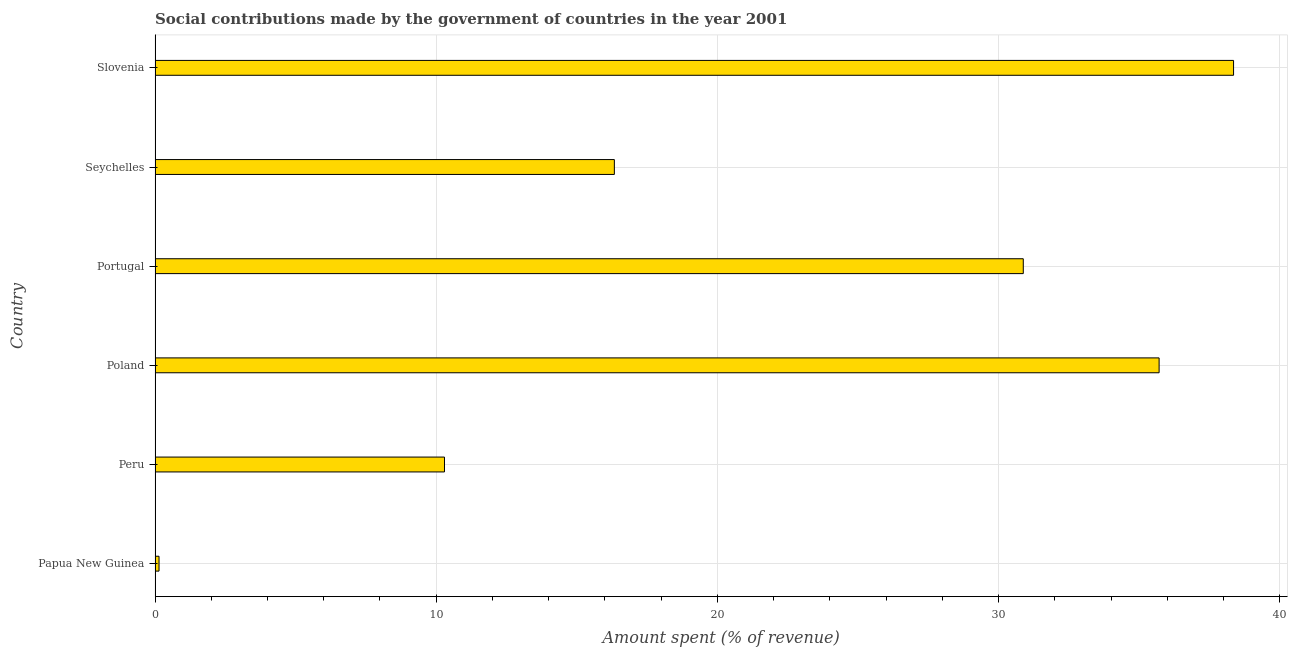What is the title of the graph?
Keep it short and to the point. Social contributions made by the government of countries in the year 2001. What is the label or title of the X-axis?
Your answer should be compact. Amount spent (% of revenue). What is the label or title of the Y-axis?
Offer a very short reply. Country. What is the amount spent in making social contributions in Poland?
Your response must be concise. 35.71. Across all countries, what is the maximum amount spent in making social contributions?
Provide a succinct answer. 38.36. Across all countries, what is the minimum amount spent in making social contributions?
Keep it short and to the point. 0.14. In which country was the amount spent in making social contributions maximum?
Give a very brief answer. Slovenia. In which country was the amount spent in making social contributions minimum?
Make the answer very short. Papua New Guinea. What is the sum of the amount spent in making social contributions?
Ensure brevity in your answer.  131.72. What is the difference between the amount spent in making social contributions in Papua New Guinea and Poland?
Your answer should be very brief. -35.57. What is the average amount spent in making social contributions per country?
Provide a succinct answer. 21.95. What is the median amount spent in making social contributions?
Your answer should be compact. 23.61. What is the ratio of the amount spent in making social contributions in Portugal to that in Slovenia?
Provide a succinct answer. 0.81. What is the difference between the highest and the second highest amount spent in making social contributions?
Ensure brevity in your answer.  2.65. What is the difference between the highest and the lowest amount spent in making social contributions?
Ensure brevity in your answer.  38.22. Are all the bars in the graph horizontal?
Your response must be concise. Yes. Are the values on the major ticks of X-axis written in scientific E-notation?
Ensure brevity in your answer.  No. What is the Amount spent (% of revenue) in Papua New Guinea?
Your response must be concise. 0.14. What is the Amount spent (% of revenue) in Peru?
Offer a very short reply. 10.29. What is the Amount spent (% of revenue) in Poland?
Your response must be concise. 35.71. What is the Amount spent (% of revenue) of Portugal?
Your answer should be compact. 30.88. What is the Amount spent (% of revenue) of Seychelles?
Give a very brief answer. 16.34. What is the Amount spent (% of revenue) of Slovenia?
Give a very brief answer. 38.36. What is the difference between the Amount spent (% of revenue) in Papua New Guinea and Peru?
Your answer should be very brief. -10.15. What is the difference between the Amount spent (% of revenue) in Papua New Guinea and Poland?
Your response must be concise. -35.57. What is the difference between the Amount spent (% of revenue) in Papua New Guinea and Portugal?
Provide a short and direct response. -30.74. What is the difference between the Amount spent (% of revenue) in Papua New Guinea and Seychelles?
Offer a terse response. -16.19. What is the difference between the Amount spent (% of revenue) in Papua New Guinea and Slovenia?
Your answer should be compact. -38.22. What is the difference between the Amount spent (% of revenue) in Peru and Poland?
Ensure brevity in your answer.  -25.42. What is the difference between the Amount spent (% of revenue) in Peru and Portugal?
Offer a terse response. -20.59. What is the difference between the Amount spent (% of revenue) in Peru and Seychelles?
Provide a short and direct response. -6.04. What is the difference between the Amount spent (% of revenue) in Peru and Slovenia?
Keep it short and to the point. -28.06. What is the difference between the Amount spent (% of revenue) in Poland and Portugal?
Your answer should be very brief. 4.83. What is the difference between the Amount spent (% of revenue) in Poland and Seychelles?
Your answer should be compact. 19.37. What is the difference between the Amount spent (% of revenue) in Poland and Slovenia?
Your response must be concise. -2.65. What is the difference between the Amount spent (% of revenue) in Portugal and Seychelles?
Give a very brief answer. 14.54. What is the difference between the Amount spent (% of revenue) in Portugal and Slovenia?
Your response must be concise. -7.48. What is the difference between the Amount spent (% of revenue) in Seychelles and Slovenia?
Provide a succinct answer. -22.02. What is the ratio of the Amount spent (% of revenue) in Papua New Guinea to that in Peru?
Provide a succinct answer. 0.01. What is the ratio of the Amount spent (% of revenue) in Papua New Guinea to that in Poland?
Offer a very short reply. 0. What is the ratio of the Amount spent (% of revenue) in Papua New Guinea to that in Portugal?
Ensure brevity in your answer.  0.01. What is the ratio of the Amount spent (% of revenue) in Papua New Guinea to that in Seychelles?
Make the answer very short. 0.01. What is the ratio of the Amount spent (% of revenue) in Papua New Guinea to that in Slovenia?
Ensure brevity in your answer.  0. What is the ratio of the Amount spent (% of revenue) in Peru to that in Poland?
Ensure brevity in your answer.  0.29. What is the ratio of the Amount spent (% of revenue) in Peru to that in Portugal?
Make the answer very short. 0.33. What is the ratio of the Amount spent (% of revenue) in Peru to that in Seychelles?
Offer a very short reply. 0.63. What is the ratio of the Amount spent (% of revenue) in Peru to that in Slovenia?
Your answer should be compact. 0.27. What is the ratio of the Amount spent (% of revenue) in Poland to that in Portugal?
Your answer should be very brief. 1.16. What is the ratio of the Amount spent (% of revenue) in Poland to that in Seychelles?
Provide a succinct answer. 2.19. What is the ratio of the Amount spent (% of revenue) in Poland to that in Slovenia?
Make the answer very short. 0.93. What is the ratio of the Amount spent (% of revenue) in Portugal to that in Seychelles?
Provide a short and direct response. 1.89. What is the ratio of the Amount spent (% of revenue) in Portugal to that in Slovenia?
Your answer should be compact. 0.81. What is the ratio of the Amount spent (% of revenue) in Seychelles to that in Slovenia?
Your answer should be very brief. 0.43. 